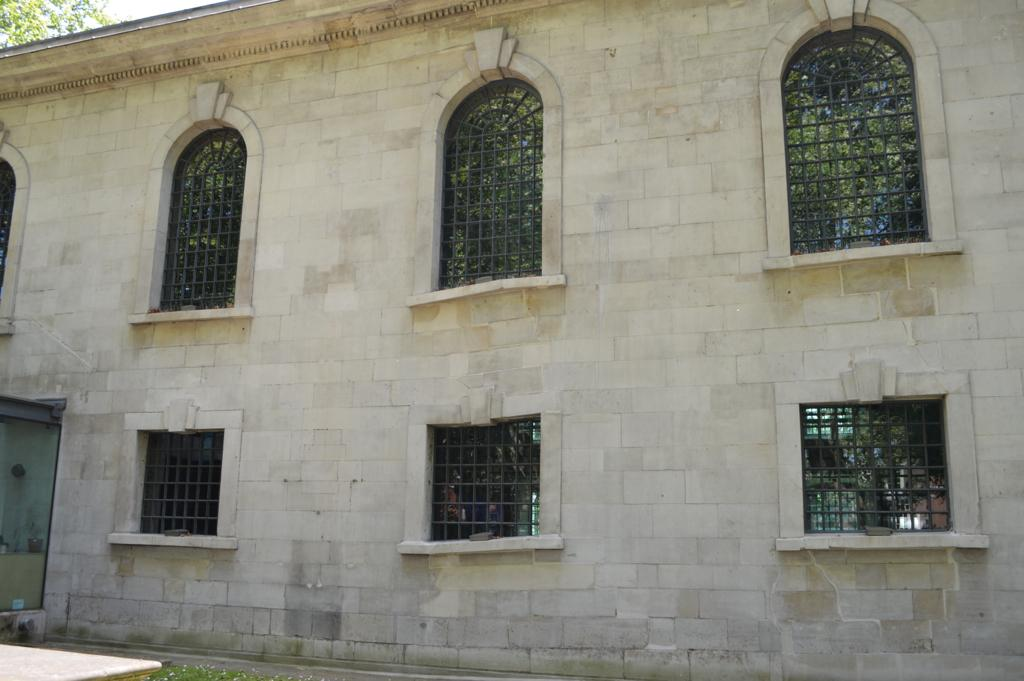What type of structure is in the image? There is an old building in the image. What can be observed about the windows at the bottom of the building? The building has square-shaped windows at the bottom. How are the windows at the top of the building different from those at the bottom? The windows at the top of the building are U-shaped. What feature do all the windows in the image have in common? The windows have iron grills. What color is the paint used to decorate the windows in the image? The provided facts do not mention any paint or color used on the windows, so we cannot determine the color of the paint. 